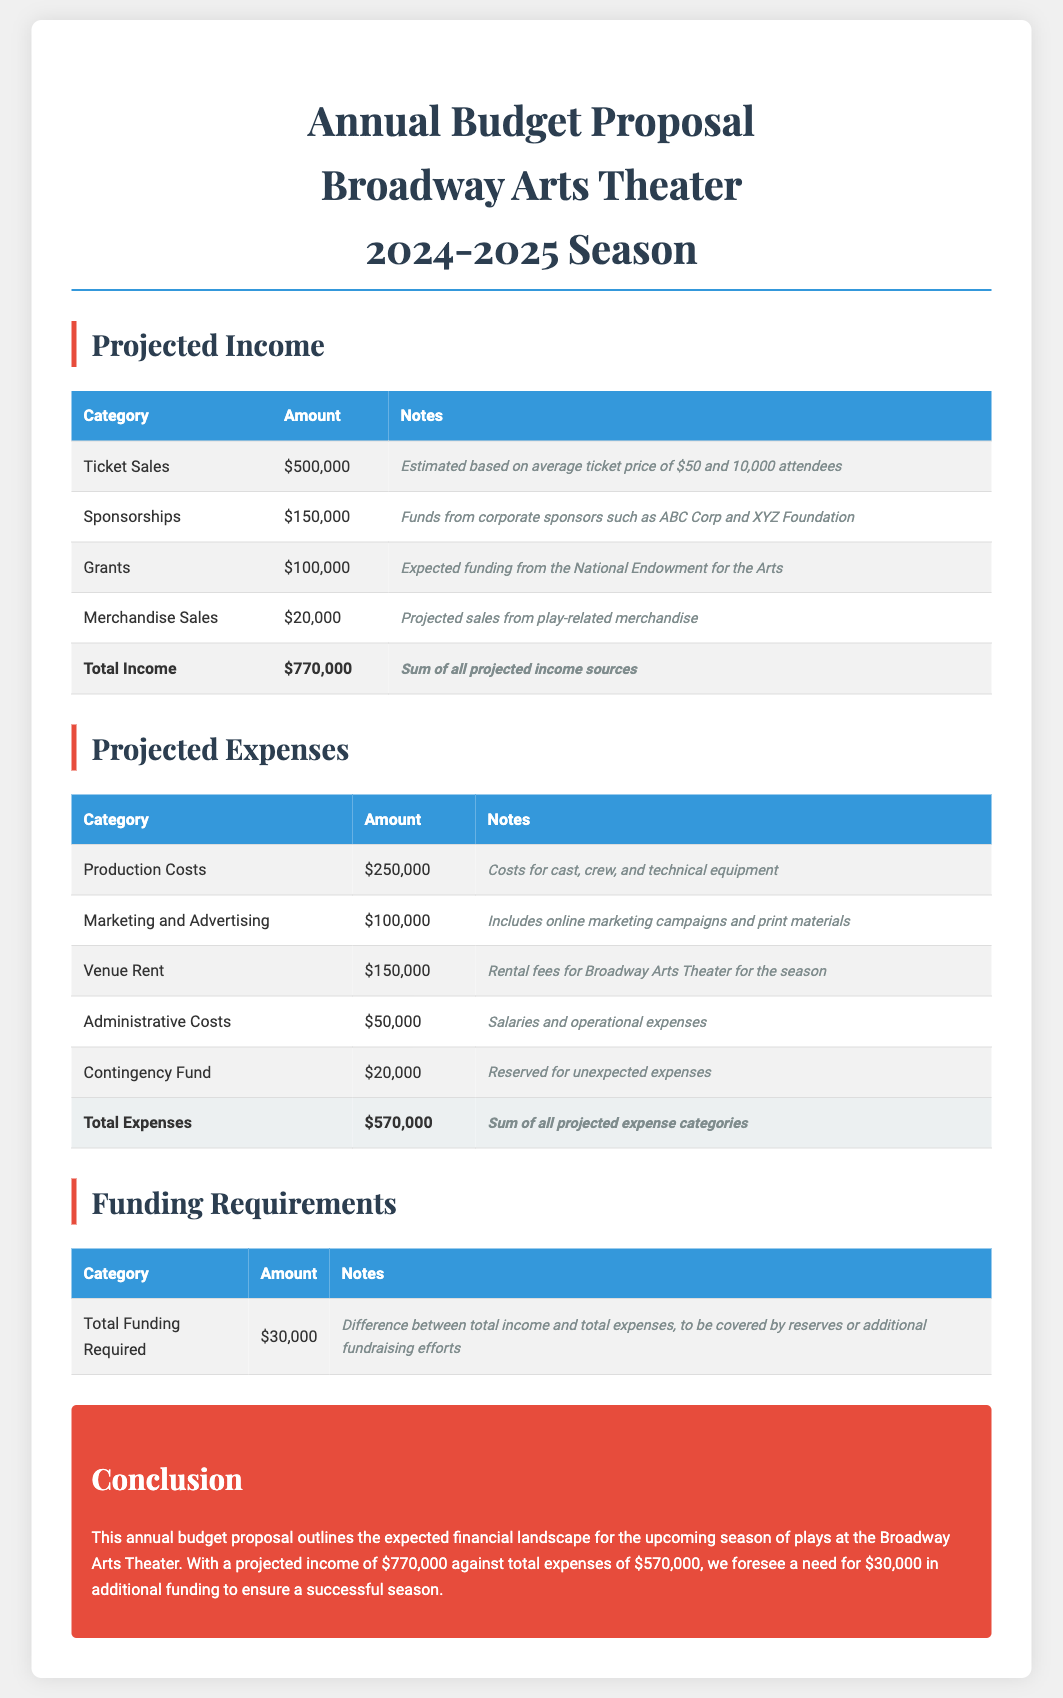What is the total income? The total income is calculated from all projected income sources, which sums up to $770,000.
Answer: $770,000 What are the main categories of projected expenses? The categories of projected expenses include Production Costs, Marketing and Advertising, Venue Rent, Administrative Costs, and Contingency Fund.
Answer: 5 categories What is the amount allocated for marketing and advertising? The document specifies $100,000 for marketing and advertising expenses.
Answer: $100,000 How much funding is required to cover the budget gap? The document states that a total funding requirement of $30,000 is needed to cover the difference between income and expenses.
Answer: $30,000 What is the estimated ticket sales amount based on attendance? Ticket sales are projected to be based on an average price and number of attendees, totaling $500,000.
Answer: $500,000 What is the total projected expenses? Total projected expenses amount to $570,000 as detailed in the document.
Answer: $570,000 What is the expected funding from grants? The document states that expected funding from grants amounts to $100,000.
Answer: $100,000 What is the purpose of the contingency fund? The contingency fund is reserved for unexpected expenses during the season.
Answer: Unexpected expenses What is the conclusion of the annual budget proposal? The conclusion summarizes the anticipated financial situation and the need for additional funding for a successful season.
Answer: Need for additional funding 